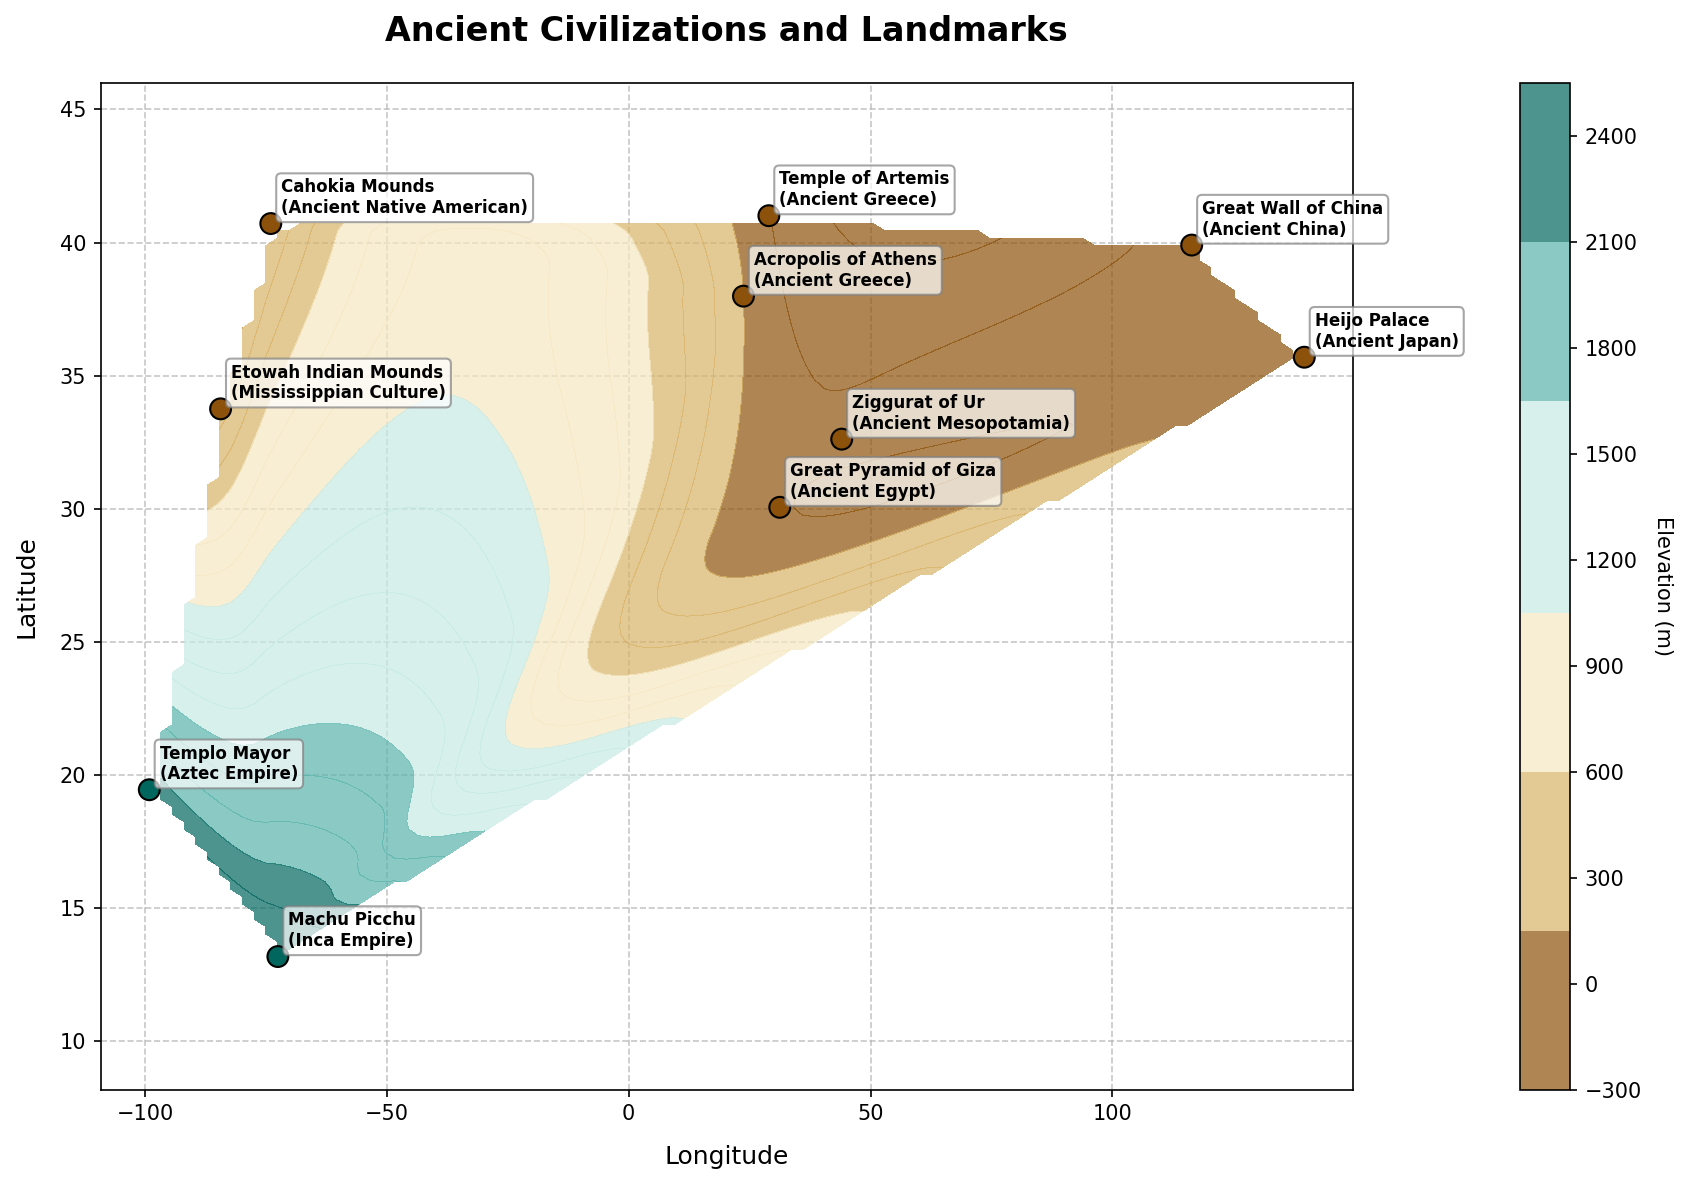What is the title of the figure? The title is typically displayed at the top of the figure. By looking there, one can see it says "Ancient Civilizations and Landmarks".
Answer: Ancient Civilizations and Landmarks What does the colorbar represent? The colorbar on the side of the plot shows the elevation in meters. This can be inferred from the label "Elevation (m)" next to the colorbar.
Answer: Elevation (m) How many ancient civilizations are labeled on the plot? By counting the unique labels for the civilization below the landmark annotations, we find there are 9 civilizations: Ancient Egypt, Ancient Mesopotamia, Ancient China, Ancient Greece (appears twice but counts as one), Ancient Native American, Ancient Japan, Inca Empire, Aztec Empire, and Mississippian Culture.
Answer: 9 What's the highest elevation landmark among the ancient civilizations and what's its elevation? By looking at the notes next to the landmarks, the one with the highest elevation is "Machu Picchu (Inca Empire)" at 2430 meters. This can be found by identifying and comparing all the elevation values associated with the landmarks.
Answer: Machu Picchu, 2430 meters Which civilization's landmark appears twice on the plot and what are those landmarks? Looking at the landmark annotations and their associated civilizations, we see "Ancient Greece" appears for "Temple of Artemis" and "Acropolis of Athens".
Answer: Ancient Greece, Temple of Artemis and Acropolis of Athens Which landmark is located at the highest latitude and what is that value? Locate the landmark with the highest y-coordinate (latitude) on the plot. The "Great Wall of China (Ancient China)" is at latitude 39.9042.
Answer: Great Wall of China, 39.9042 Between the Great Pyramid of Giza and Templo Mayor, which has a higher elevation? The Great Pyramid of Giza (Ancient Egypt) has an elevation of 13 meters, and Templo Mayor (Aztec Empire) has an elevation of 2230 meters. By comparison, Templo Mayor has a higher elevation.
Answer: Templo Mayor What is the average elevation of the landmarks from the Ancient Greece civilization? The elevations of "Temple of Artemis" and "Acropolis of Athens" are 5 and 150 meters, respectively. The average is calculated by summing the elevations and dividing by the number of landmarks: (5 + 150)/2 = 77.5 meters.
Answer: 77.5 meters Which landmark is located closest to the equator (latitude 0)? The landmark closest to latitude 0 is Machu Picchu (Inca Empire) at latitude 13.1631. This can be found by identifying the landmark with the smallest absolute value of latitude.
Answer: Machu Picchu 